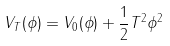<formula> <loc_0><loc_0><loc_500><loc_500>V _ { T } ( \phi ) = V _ { 0 } ( \phi ) + \frac { 1 } { 2 } T ^ { 2 } \phi ^ { 2 }</formula> 